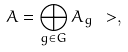Convert formula to latex. <formula><loc_0><loc_0><loc_500><loc_500>A = \bigoplus _ { g \in G } A _ { g } \ > ,</formula> 